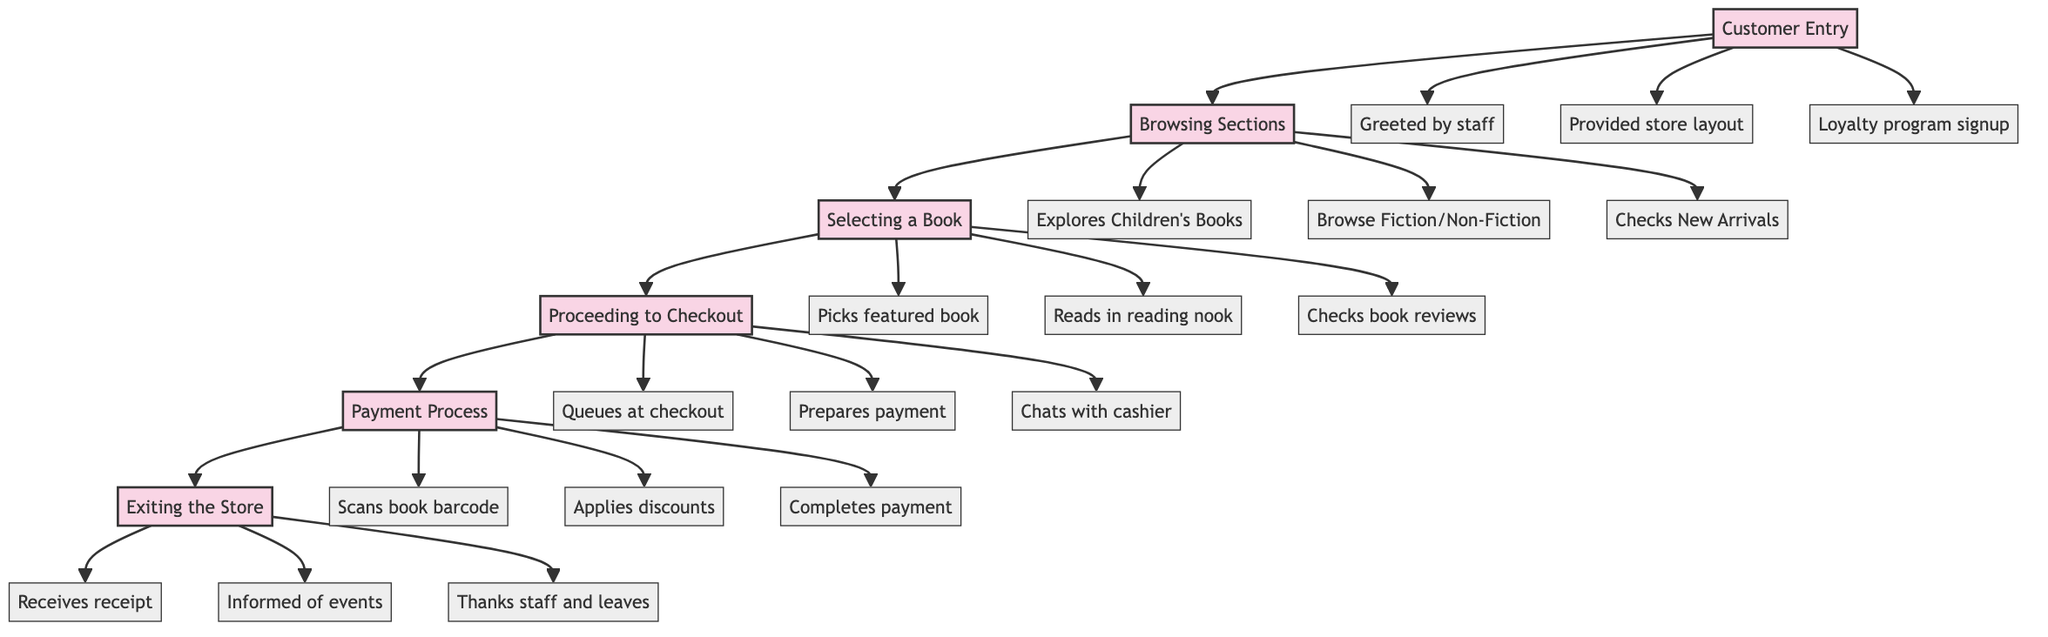What is the first stage in the customer purchase journey? The first stage, as indicated in the diagram, is labeled as "Customer Entry." This illustrates the initial point where customers enter the bookstore.
Answer: Customer Entry How many stages are in the customer purchase journey? By counting the stages shown in the diagram, we can see there are six stages: Customer Entry, Browsing Sections, Selecting a Book, Proceeding to Checkout, Payment Process, and Exiting the Store.
Answer: Six Which action follows "Selecting a Book"? The action that follows "Selecting a Book" is represented by an arrow leading to the next stage, which is "Proceeding to Checkout," indicating that once a book is selected, the next step is heading to the checkout.
Answer: Proceeding to Checkout What action is taken during the "Payment Process" stage? During the "Payment Process" stage, one of the actions taken is "Completes payment via credit card, cash, or mobile payment," indicating the final step in payment.
Answer: Completes payment via credit card, cash, or mobile payment What is the last action a customer takes before leaving the store? The last action taken before leaving the store is "Thanks the staff and leaves the store," which signifies the closure of the customer journey as they exit.
Answer: Thanks the staff and leaves the store Which section do customers explore while browsing? Customers explore the "Children's Books" section while browsing, as indicated among the various actions listed in the "Browsing Sections" stage.
Answer: Children's Books What happens after a customer examines a book in the reading nook? After a customer examines a book in the reading nook, the next action based on the flow is selecting a book, which is part of the following stage "Selecting a Book."
Answer: Selecting a Book How does a customer engage with the cashier during checkout? During checkout, a customer engages with the cashier by "Chats with cashier," indicating a social interaction that occurs at the checkout stage.
Answer: Chats with cashier What does the customer receive upon exiting the store? Upon exiting, the customer receives a "receipt and store bookmark," which is part of the final actions taken in the journey.
Answer: Receipt and store bookmark 